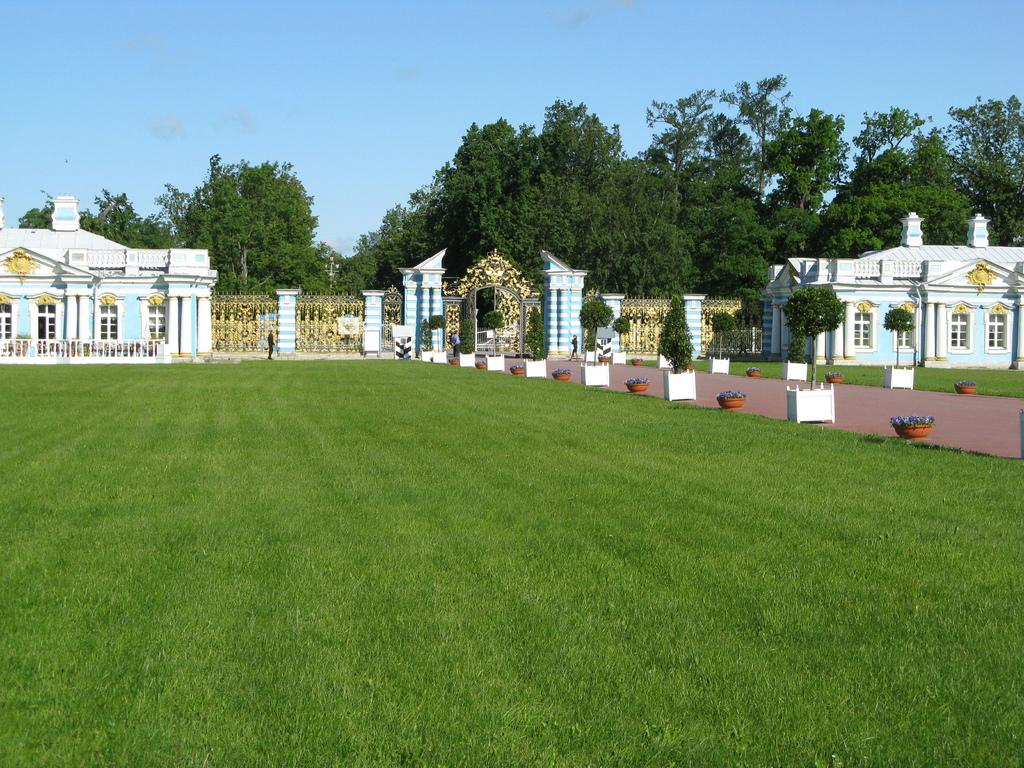What type of vegetation can be seen in the foreground of the picture? There is grass in the foreground of the picture. What can be found in the center of the picture? There are trees, buildings, a railing, a gate, plants, and flower pots in the center of the picture. What is the weather like in the image? The weather is sunny. How many dust particles can be seen on the railing in the image? There is no mention of dust particles in the image, so it is impossible to determine their number. What is in the pocket of the person standing near the gate in the image? There is no person or pocket mentioned in the image, so it is impossible to determine what might be inside. 